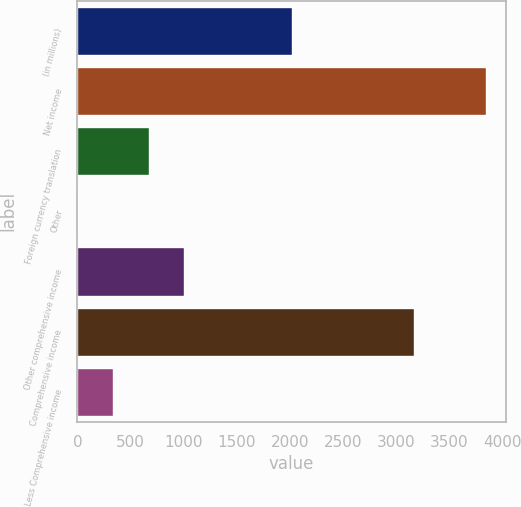Convert chart to OTSL. <chart><loc_0><loc_0><loc_500><loc_500><bar_chart><fcel>(in millions)<fcel>Net income<fcel>Foreign currency translation<fcel>Other<fcel>Other comprehensive income<fcel>Comprehensive income<fcel>Less Comprehensive income<nl><fcel>2015<fcel>3840<fcel>672<fcel>2<fcel>1007<fcel>3170<fcel>337<nl></chart> 